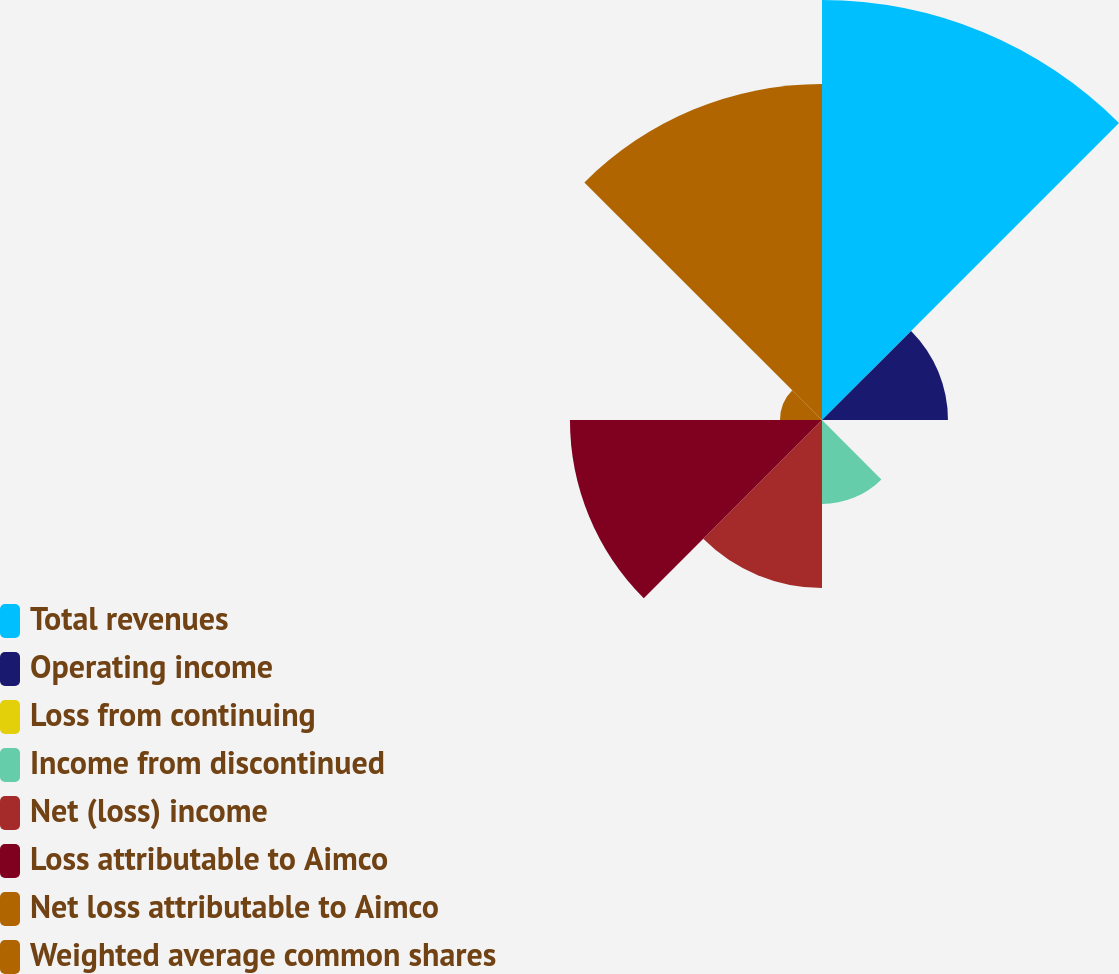Convert chart to OTSL. <chart><loc_0><loc_0><loc_500><loc_500><pie_chart><fcel>Total revenues<fcel>Operating income<fcel>Loss from continuing<fcel>Income from discontinued<fcel>Net (loss) income<fcel>Loss attributable to Aimco<fcel>Net loss attributable to Aimco<fcel>Weighted average common shares<nl><fcel>29.41%<fcel>8.82%<fcel>0.0%<fcel>5.88%<fcel>11.76%<fcel>17.65%<fcel>2.94%<fcel>23.53%<nl></chart> 